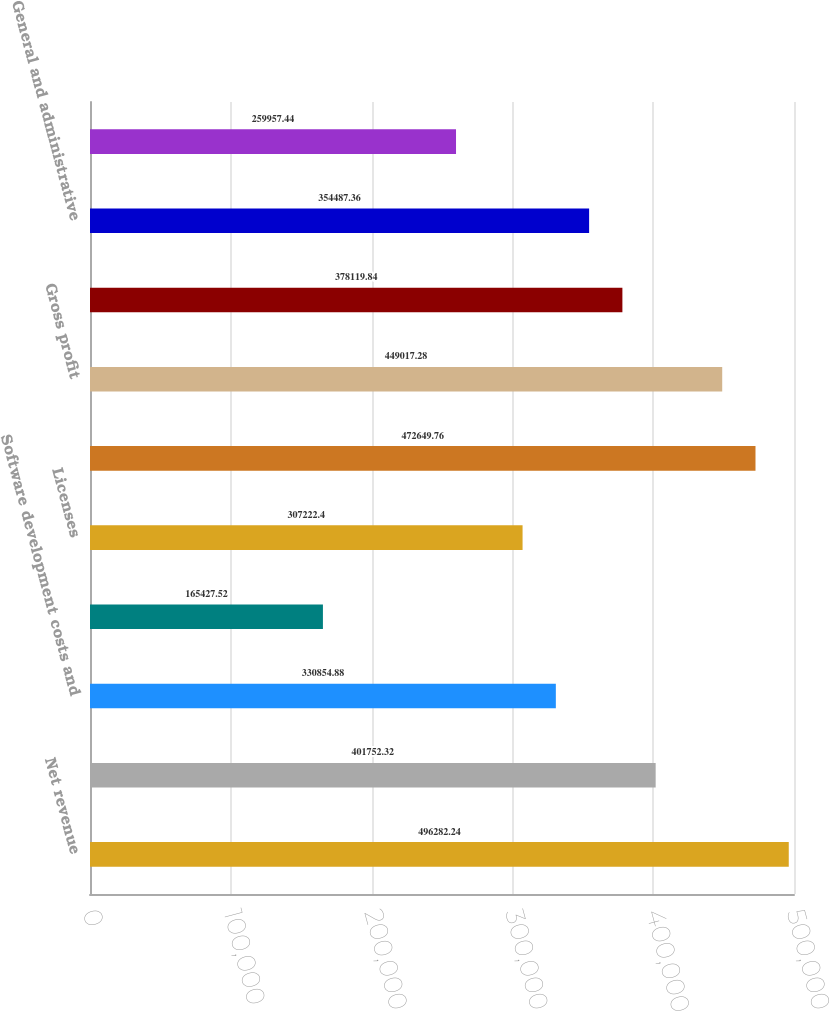Convert chart to OTSL. <chart><loc_0><loc_0><loc_500><loc_500><bar_chart><fcel>Net revenue<fcel>Product costs<fcel>Software development costs and<fcel>Internal royalties<fcel>Licenses<fcel>Cost of goods sold<fcel>Gross profit<fcel>Selling and marketing<fcel>General and administrative<fcel>Research and development<nl><fcel>496282<fcel>401752<fcel>330855<fcel>165428<fcel>307222<fcel>472650<fcel>449017<fcel>378120<fcel>354487<fcel>259957<nl></chart> 